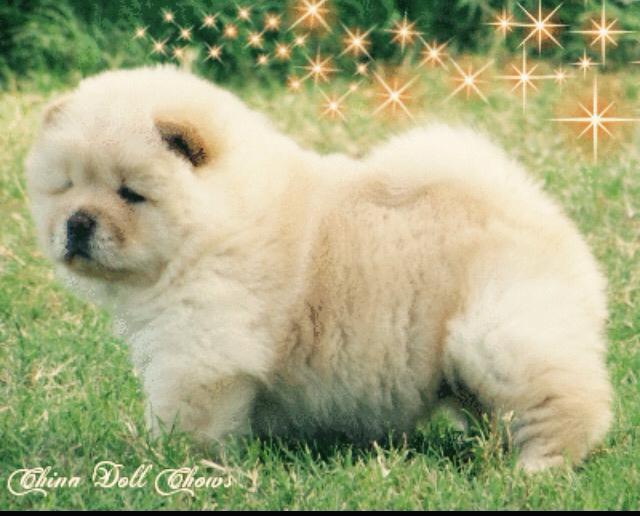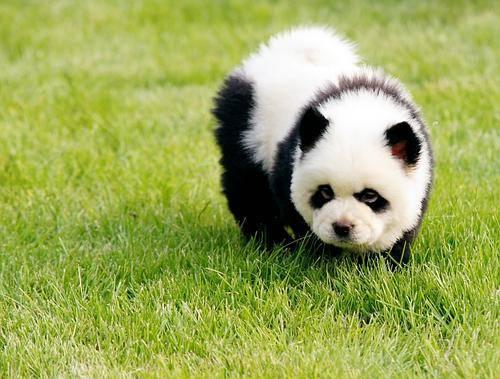The first image is the image on the left, the second image is the image on the right. Considering the images on both sides, is "Two dogs are standing." valid? Answer yes or no. Yes. The first image is the image on the left, the second image is the image on the right. Evaluate the accuracy of this statement regarding the images: "Each image shows a chow dog standing on grass, and one image shows a dog standing with its body turned leftward.". Is it true? Answer yes or no. Yes. 